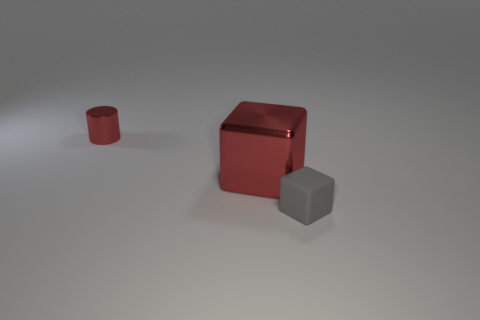How many objects are tiny gray matte things or red shiny cylinders?
Provide a succinct answer. 2. The object that is behind the cube that is behind the tiny thing right of the small red cylinder is what shape?
Keep it short and to the point. Cylinder. Are the tiny thing that is to the right of the tiny metallic thing and the block behind the tiny rubber cube made of the same material?
Give a very brief answer. No. What is the material of the small object that is the same shape as the large red object?
Give a very brief answer. Rubber. Is there anything else that has the same size as the red metal cylinder?
Offer a very short reply. Yes. There is a red shiny object in front of the tiny metallic object; is its shape the same as the thing in front of the large shiny block?
Provide a short and direct response. Yes. Are there fewer metallic things on the right side of the large cube than gray matte blocks that are on the right side of the cylinder?
Offer a terse response. Yes. How many other things are there of the same shape as the tiny red metallic thing?
Offer a very short reply. 0. What shape is the large red object that is made of the same material as the cylinder?
Provide a short and direct response. Cube. There is a thing that is in front of the shiny cylinder and left of the gray block; what is its color?
Provide a short and direct response. Red. 